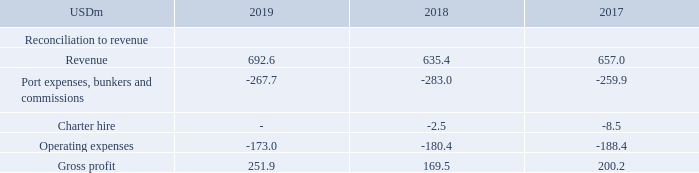ALTERNATIVE PERFORMANCE MEASURES
Gross profit:
TORM defines Gross profit, a performance measure, as revenue less port expenses, bunkers and commissions, charter hire and operating expenses. The Company reports Gross profit because we believe it provides additional meaningful information to investors, as Gross profit measures the net earnings from shipping activities. Gross profit is calculated as follows:
How does TORM define gross profit? Torm defines gross profit, a performance measure, as revenue less port expenses, bunkers and commissions, charter hire and operating expenses. Why does the company reports gross profit? It provides additional meaningful information to investors, as gross profit measures the net earnings from shipping activities. What are the components under Reconciliation to revenue when calculating the gross profit? Revenue, port expenses, bunkers and commissions, charter hire, operating expenses. In which year was the amount of operating expenses the largest? |188.4|>|180.4|>|173.0|
Answer: 2017. What was the change in gross profit in 2019 from 2018?
Answer scale should be: million. 251.9-169.5
Answer: 82.4. What was the percentage change in gross profit in 2019 from 2018?
Answer scale should be: percent. (251.9-169.5)/169.5
Answer: 48.61. 